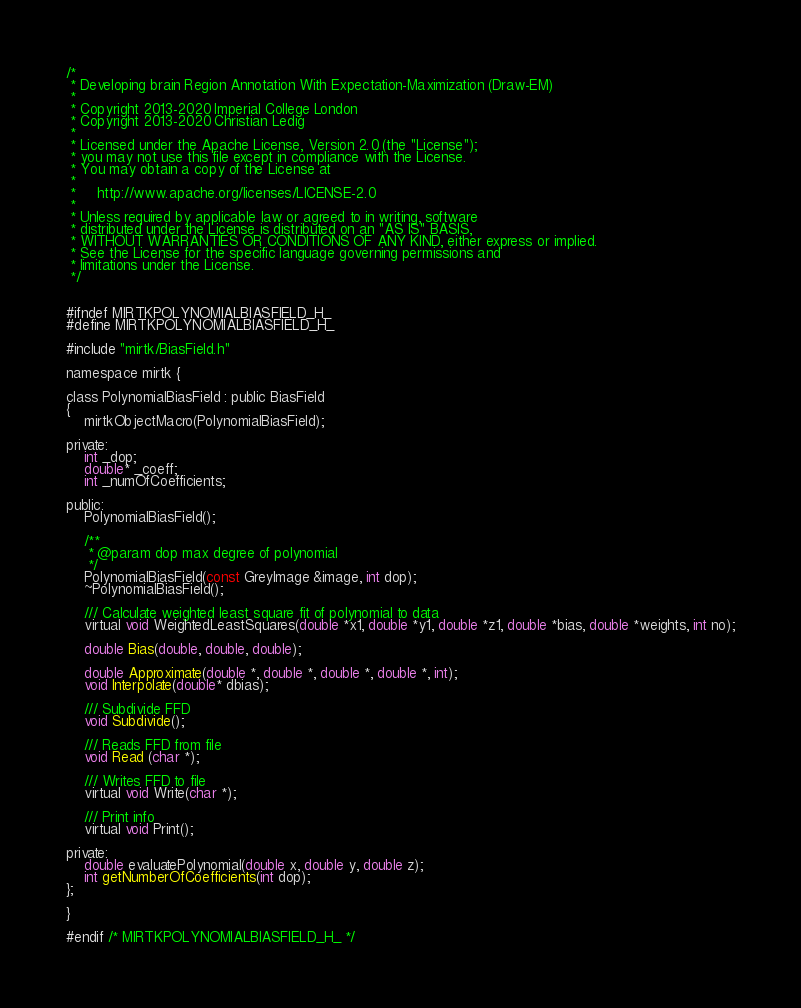<code> <loc_0><loc_0><loc_500><loc_500><_C_>/*
 * Developing brain Region Annotation With Expectation-Maximization (Draw-EM)
 *
 * Copyright 2013-2020 Imperial College London
 * Copyright 2013-2020 Christian Ledig
 *
 * Licensed under the Apache License, Version 2.0 (the "License");
 * you may not use this file except in compliance with the License.
 * You may obtain a copy of the License at
 *
 *     http://www.apache.org/licenses/LICENSE-2.0
 *
 * Unless required by applicable law or agreed to in writing, software
 * distributed under the License is distributed on an "AS IS" BASIS,
 * WITHOUT WARRANTIES OR CONDITIONS OF ANY KIND, either express or implied.
 * See the License for the specific language governing permissions and
 * limitations under the License.
 */


#ifndef MIRTKPOLYNOMIALBIASFIELD_H_
#define MIRTKPOLYNOMIALBIASFIELD_H_

#include "mirtk/BiasField.h"

namespace mirtk {

class PolynomialBiasField : public BiasField
{
	mirtkObjectMacro(PolynomialBiasField);

private:
	int _dop;
	double* _coeff;
	int _numOfCoefficients;

public:
	PolynomialBiasField();

	/**
	 * @param dop max degree of polynomial
	 */
	PolynomialBiasField(const GreyImage &image, int dop);
	~PolynomialBiasField();

	/// Calculate weighted least square fit of polynomial to data
	virtual void WeightedLeastSquares(double *x1, double *y1, double *z1, double *bias, double *weights, int no);

	double Bias(double, double, double);

	double Approximate(double *, double *, double *, double *, int);
	void Interpolate(double* dbias);

	/// Subdivide FFD
	void Subdivide();

	/// Reads FFD from file
	void Read (char *);

	/// Writes FFD to file
	virtual void Write(char *);

	/// Print info
	virtual void Print();

private:
	double evaluatePolynomial(double x, double y, double z);
	int getNumberOfCoefficients(int dop);
};

}

#endif /* MIRTKPOLYNOMIALBIASFIELD_H_ */
</code> 